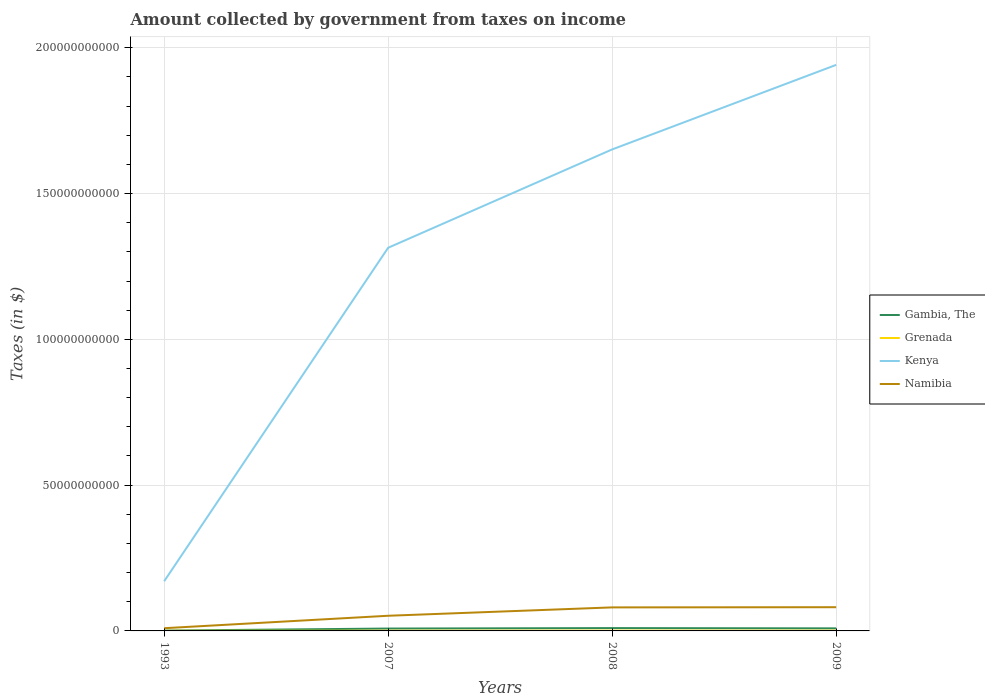How many different coloured lines are there?
Keep it short and to the point. 4. Does the line corresponding to Grenada intersect with the line corresponding to Gambia, The?
Ensure brevity in your answer.  No. Across all years, what is the maximum amount collected by government from taxes on income in Grenada?
Ensure brevity in your answer.  3.64e+07. What is the total amount collected by government from taxes on income in Namibia in the graph?
Provide a succinct answer. -2.94e+09. What is the difference between the highest and the second highest amount collected by government from taxes on income in Gambia, The?
Provide a succinct answer. 8.57e+08. Is the amount collected by government from taxes on income in Gambia, The strictly greater than the amount collected by government from taxes on income in Namibia over the years?
Your answer should be very brief. Yes. How many years are there in the graph?
Make the answer very short. 4. What is the difference between two consecutive major ticks on the Y-axis?
Offer a terse response. 5.00e+1. Are the values on the major ticks of Y-axis written in scientific E-notation?
Your answer should be very brief. No. How many legend labels are there?
Keep it short and to the point. 4. What is the title of the graph?
Offer a very short reply. Amount collected by government from taxes on income. Does "Aruba" appear as one of the legend labels in the graph?
Your answer should be very brief. No. What is the label or title of the Y-axis?
Give a very brief answer. Taxes (in $). What is the Taxes (in $) in Gambia, The in 1993?
Ensure brevity in your answer.  1.15e+08. What is the Taxes (in $) in Grenada in 1993?
Keep it short and to the point. 3.64e+07. What is the Taxes (in $) in Kenya in 1993?
Provide a succinct answer. 1.70e+1. What is the Taxes (in $) in Namibia in 1993?
Offer a very short reply. 9.30e+08. What is the Taxes (in $) of Gambia, The in 2007?
Ensure brevity in your answer.  8.16e+08. What is the Taxes (in $) in Grenada in 2007?
Your answer should be very brief. 7.48e+07. What is the Taxes (in $) in Kenya in 2007?
Offer a very short reply. 1.31e+11. What is the Taxes (in $) of Namibia in 2007?
Your response must be concise. 5.20e+09. What is the Taxes (in $) in Gambia, The in 2008?
Ensure brevity in your answer.  9.72e+08. What is the Taxes (in $) of Grenada in 2008?
Offer a very short reply. 9.46e+07. What is the Taxes (in $) in Kenya in 2008?
Provide a short and direct response. 1.65e+11. What is the Taxes (in $) of Namibia in 2008?
Your response must be concise. 8.07e+09. What is the Taxes (in $) of Gambia, The in 2009?
Keep it short and to the point. 8.81e+08. What is the Taxes (in $) in Grenada in 2009?
Your answer should be compact. 8.72e+07. What is the Taxes (in $) in Kenya in 2009?
Give a very brief answer. 1.94e+11. What is the Taxes (in $) in Namibia in 2009?
Offer a terse response. 8.14e+09. Across all years, what is the maximum Taxes (in $) of Gambia, The?
Give a very brief answer. 9.72e+08. Across all years, what is the maximum Taxes (in $) in Grenada?
Your response must be concise. 9.46e+07. Across all years, what is the maximum Taxes (in $) in Kenya?
Provide a short and direct response. 1.94e+11. Across all years, what is the maximum Taxes (in $) in Namibia?
Your answer should be compact. 8.14e+09. Across all years, what is the minimum Taxes (in $) in Gambia, The?
Offer a terse response. 1.15e+08. Across all years, what is the minimum Taxes (in $) of Grenada?
Make the answer very short. 3.64e+07. Across all years, what is the minimum Taxes (in $) in Kenya?
Your answer should be compact. 1.70e+1. Across all years, what is the minimum Taxes (in $) in Namibia?
Provide a short and direct response. 9.30e+08. What is the total Taxes (in $) of Gambia, The in the graph?
Offer a terse response. 2.78e+09. What is the total Taxes (in $) in Grenada in the graph?
Your response must be concise. 2.93e+08. What is the total Taxes (in $) of Kenya in the graph?
Offer a terse response. 5.08e+11. What is the total Taxes (in $) in Namibia in the graph?
Provide a short and direct response. 2.23e+1. What is the difference between the Taxes (in $) in Gambia, The in 1993 and that in 2007?
Your answer should be compact. -7.02e+08. What is the difference between the Taxes (in $) of Grenada in 1993 and that in 2007?
Offer a very short reply. -3.84e+07. What is the difference between the Taxes (in $) of Kenya in 1993 and that in 2007?
Offer a terse response. -1.14e+11. What is the difference between the Taxes (in $) in Namibia in 1993 and that in 2007?
Provide a succinct answer. -4.27e+09. What is the difference between the Taxes (in $) in Gambia, The in 1993 and that in 2008?
Provide a succinct answer. -8.57e+08. What is the difference between the Taxes (in $) in Grenada in 1993 and that in 2008?
Give a very brief answer. -5.82e+07. What is the difference between the Taxes (in $) of Kenya in 1993 and that in 2008?
Provide a short and direct response. -1.48e+11. What is the difference between the Taxes (in $) in Namibia in 1993 and that in 2008?
Provide a succinct answer. -7.14e+09. What is the difference between the Taxes (in $) of Gambia, The in 1993 and that in 2009?
Your response must be concise. -7.67e+08. What is the difference between the Taxes (in $) in Grenada in 1993 and that in 2009?
Your answer should be very brief. -5.08e+07. What is the difference between the Taxes (in $) of Kenya in 1993 and that in 2009?
Give a very brief answer. -1.77e+11. What is the difference between the Taxes (in $) of Namibia in 1993 and that in 2009?
Your response must be concise. -7.21e+09. What is the difference between the Taxes (in $) in Gambia, The in 2007 and that in 2008?
Give a very brief answer. -1.56e+08. What is the difference between the Taxes (in $) in Grenada in 2007 and that in 2008?
Give a very brief answer. -1.98e+07. What is the difference between the Taxes (in $) in Kenya in 2007 and that in 2008?
Give a very brief answer. -3.37e+1. What is the difference between the Taxes (in $) of Namibia in 2007 and that in 2008?
Offer a very short reply. -2.87e+09. What is the difference between the Taxes (in $) of Gambia, The in 2007 and that in 2009?
Make the answer very short. -6.50e+07. What is the difference between the Taxes (in $) in Grenada in 2007 and that in 2009?
Provide a succinct answer. -1.24e+07. What is the difference between the Taxes (in $) in Kenya in 2007 and that in 2009?
Give a very brief answer. -6.27e+1. What is the difference between the Taxes (in $) of Namibia in 2007 and that in 2009?
Give a very brief answer. -2.94e+09. What is the difference between the Taxes (in $) in Gambia, The in 2008 and that in 2009?
Your answer should be compact. 9.08e+07. What is the difference between the Taxes (in $) in Grenada in 2008 and that in 2009?
Your answer should be very brief. 7.40e+06. What is the difference between the Taxes (in $) of Kenya in 2008 and that in 2009?
Provide a short and direct response. -2.90e+1. What is the difference between the Taxes (in $) in Namibia in 2008 and that in 2009?
Offer a very short reply. -6.70e+07. What is the difference between the Taxes (in $) of Gambia, The in 1993 and the Taxes (in $) of Grenada in 2007?
Offer a terse response. 3.99e+07. What is the difference between the Taxes (in $) of Gambia, The in 1993 and the Taxes (in $) of Kenya in 2007?
Keep it short and to the point. -1.31e+11. What is the difference between the Taxes (in $) of Gambia, The in 1993 and the Taxes (in $) of Namibia in 2007?
Your response must be concise. -5.09e+09. What is the difference between the Taxes (in $) in Grenada in 1993 and the Taxes (in $) in Kenya in 2007?
Provide a succinct answer. -1.31e+11. What is the difference between the Taxes (in $) in Grenada in 1993 and the Taxes (in $) in Namibia in 2007?
Keep it short and to the point. -5.16e+09. What is the difference between the Taxes (in $) of Kenya in 1993 and the Taxes (in $) of Namibia in 2007?
Your answer should be very brief. 1.18e+1. What is the difference between the Taxes (in $) in Gambia, The in 1993 and the Taxes (in $) in Grenada in 2008?
Provide a succinct answer. 2.01e+07. What is the difference between the Taxes (in $) in Gambia, The in 1993 and the Taxes (in $) in Kenya in 2008?
Make the answer very short. -1.65e+11. What is the difference between the Taxes (in $) of Gambia, The in 1993 and the Taxes (in $) of Namibia in 2008?
Keep it short and to the point. -7.95e+09. What is the difference between the Taxes (in $) in Grenada in 1993 and the Taxes (in $) in Kenya in 2008?
Your answer should be very brief. -1.65e+11. What is the difference between the Taxes (in $) in Grenada in 1993 and the Taxes (in $) in Namibia in 2008?
Offer a terse response. -8.03e+09. What is the difference between the Taxes (in $) of Kenya in 1993 and the Taxes (in $) of Namibia in 2008?
Offer a very short reply. 8.96e+09. What is the difference between the Taxes (in $) of Gambia, The in 1993 and the Taxes (in $) of Grenada in 2009?
Your answer should be very brief. 2.75e+07. What is the difference between the Taxes (in $) of Gambia, The in 1993 and the Taxes (in $) of Kenya in 2009?
Ensure brevity in your answer.  -1.94e+11. What is the difference between the Taxes (in $) in Gambia, The in 1993 and the Taxes (in $) in Namibia in 2009?
Your answer should be very brief. -8.02e+09. What is the difference between the Taxes (in $) of Grenada in 1993 and the Taxes (in $) of Kenya in 2009?
Make the answer very short. -1.94e+11. What is the difference between the Taxes (in $) in Grenada in 1993 and the Taxes (in $) in Namibia in 2009?
Make the answer very short. -8.10e+09. What is the difference between the Taxes (in $) of Kenya in 1993 and the Taxes (in $) of Namibia in 2009?
Provide a short and direct response. 8.89e+09. What is the difference between the Taxes (in $) in Gambia, The in 2007 and the Taxes (in $) in Grenada in 2008?
Your response must be concise. 7.22e+08. What is the difference between the Taxes (in $) of Gambia, The in 2007 and the Taxes (in $) of Kenya in 2008?
Your answer should be compact. -1.64e+11. What is the difference between the Taxes (in $) in Gambia, The in 2007 and the Taxes (in $) in Namibia in 2008?
Your answer should be compact. -7.25e+09. What is the difference between the Taxes (in $) in Grenada in 2007 and the Taxes (in $) in Kenya in 2008?
Give a very brief answer. -1.65e+11. What is the difference between the Taxes (in $) in Grenada in 2007 and the Taxes (in $) in Namibia in 2008?
Keep it short and to the point. -7.99e+09. What is the difference between the Taxes (in $) of Kenya in 2007 and the Taxes (in $) of Namibia in 2008?
Your answer should be compact. 1.23e+11. What is the difference between the Taxes (in $) of Gambia, The in 2007 and the Taxes (in $) of Grenada in 2009?
Make the answer very short. 7.29e+08. What is the difference between the Taxes (in $) of Gambia, The in 2007 and the Taxes (in $) of Kenya in 2009?
Keep it short and to the point. -1.93e+11. What is the difference between the Taxes (in $) of Gambia, The in 2007 and the Taxes (in $) of Namibia in 2009?
Ensure brevity in your answer.  -7.32e+09. What is the difference between the Taxes (in $) in Grenada in 2007 and the Taxes (in $) in Kenya in 2009?
Make the answer very short. -1.94e+11. What is the difference between the Taxes (in $) of Grenada in 2007 and the Taxes (in $) of Namibia in 2009?
Your answer should be very brief. -8.06e+09. What is the difference between the Taxes (in $) in Kenya in 2007 and the Taxes (in $) in Namibia in 2009?
Make the answer very short. 1.23e+11. What is the difference between the Taxes (in $) of Gambia, The in 2008 and the Taxes (in $) of Grenada in 2009?
Your answer should be compact. 8.85e+08. What is the difference between the Taxes (in $) in Gambia, The in 2008 and the Taxes (in $) in Kenya in 2009?
Your answer should be compact. -1.93e+11. What is the difference between the Taxes (in $) of Gambia, The in 2008 and the Taxes (in $) of Namibia in 2009?
Provide a succinct answer. -7.16e+09. What is the difference between the Taxes (in $) in Grenada in 2008 and the Taxes (in $) in Kenya in 2009?
Your response must be concise. -1.94e+11. What is the difference between the Taxes (in $) in Grenada in 2008 and the Taxes (in $) in Namibia in 2009?
Provide a short and direct response. -8.04e+09. What is the difference between the Taxes (in $) of Kenya in 2008 and the Taxes (in $) of Namibia in 2009?
Make the answer very short. 1.57e+11. What is the average Taxes (in $) in Gambia, The per year?
Ensure brevity in your answer.  6.96e+08. What is the average Taxes (in $) in Grenada per year?
Offer a very short reply. 7.33e+07. What is the average Taxes (in $) of Kenya per year?
Provide a short and direct response. 1.27e+11. What is the average Taxes (in $) of Namibia per year?
Keep it short and to the point. 5.58e+09. In the year 1993, what is the difference between the Taxes (in $) in Gambia, The and Taxes (in $) in Grenada?
Your response must be concise. 7.83e+07. In the year 1993, what is the difference between the Taxes (in $) of Gambia, The and Taxes (in $) of Kenya?
Ensure brevity in your answer.  -1.69e+1. In the year 1993, what is the difference between the Taxes (in $) of Gambia, The and Taxes (in $) of Namibia?
Give a very brief answer. -8.16e+08. In the year 1993, what is the difference between the Taxes (in $) of Grenada and Taxes (in $) of Kenya?
Provide a succinct answer. -1.70e+1. In the year 1993, what is the difference between the Taxes (in $) in Grenada and Taxes (in $) in Namibia?
Your answer should be very brief. -8.94e+08. In the year 1993, what is the difference between the Taxes (in $) in Kenya and Taxes (in $) in Namibia?
Provide a succinct answer. 1.61e+1. In the year 2007, what is the difference between the Taxes (in $) in Gambia, The and Taxes (in $) in Grenada?
Offer a terse response. 7.42e+08. In the year 2007, what is the difference between the Taxes (in $) of Gambia, The and Taxes (in $) of Kenya?
Provide a succinct answer. -1.31e+11. In the year 2007, what is the difference between the Taxes (in $) of Gambia, The and Taxes (in $) of Namibia?
Offer a very short reply. -4.38e+09. In the year 2007, what is the difference between the Taxes (in $) of Grenada and Taxes (in $) of Kenya?
Ensure brevity in your answer.  -1.31e+11. In the year 2007, what is the difference between the Taxes (in $) in Grenada and Taxes (in $) in Namibia?
Provide a succinct answer. -5.13e+09. In the year 2007, what is the difference between the Taxes (in $) in Kenya and Taxes (in $) in Namibia?
Offer a terse response. 1.26e+11. In the year 2008, what is the difference between the Taxes (in $) of Gambia, The and Taxes (in $) of Grenada?
Your answer should be very brief. 8.78e+08. In the year 2008, what is the difference between the Taxes (in $) of Gambia, The and Taxes (in $) of Kenya?
Provide a succinct answer. -1.64e+11. In the year 2008, what is the difference between the Taxes (in $) in Gambia, The and Taxes (in $) in Namibia?
Your answer should be compact. -7.10e+09. In the year 2008, what is the difference between the Taxes (in $) in Grenada and Taxes (in $) in Kenya?
Ensure brevity in your answer.  -1.65e+11. In the year 2008, what is the difference between the Taxes (in $) of Grenada and Taxes (in $) of Namibia?
Your answer should be compact. -7.98e+09. In the year 2008, what is the difference between the Taxes (in $) of Kenya and Taxes (in $) of Namibia?
Offer a very short reply. 1.57e+11. In the year 2009, what is the difference between the Taxes (in $) in Gambia, The and Taxes (in $) in Grenada?
Provide a short and direct response. 7.94e+08. In the year 2009, what is the difference between the Taxes (in $) in Gambia, The and Taxes (in $) in Kenya?
Make the answer very short. -1.93e+11. In the year 2009, what is the difference between the Taxes (in $) of Gambia, The and Taxes (in $) of Namibia?
Ensure brevity in your answer.  -7.26e+09. In the year 2009, what is the difference between the Taxes (in $) of Grenada and Taxes (in $) of Kenya?
Your response must be concise. -1.94e+11. In the year 2009, what is the difference between the Taxes (in $) in Grenada and Taxes (in $) in Namibia?
Make the answer very short. -8.05e+09. In the year 2009, what is the difference between the Taxes (in $) in Kenya and Taxes (in $) in Namibia?
Your answer should be very brief. 1.86e+11. What is the ratio of the Taxes (in $) of Gambia, The in 1993 to that in 2007?
Offer a terse response. 0.14. What is the ratio of the Taxes (in $) in Grenada in 1993 to that in 2007?
Offer a very short reply. 0.49. What is the ratio of the Taxes (in $) of Kenya in 1993 to that in 2007?
Make the answer very short. 0.13. What is the ratio of the Taxes (in $) of Namibia in 1993 to that in 2007?
Your response must be concise. 0.18. What is the ratio of the Taxes (in $) of Gambia, The in 1993 to that in 2008?
Your answer should be very brief. 0.12. What is the ratio of the Taxes (in $) in Grenada in 1993 to that in 2008?
Offer a very short reply. 0.39. What is the ratio of the Taxes (in $) of Kenya in 1993 to that in 2008?
Your answer should be compact. 0.1. What is the ratio of the Taxes (in $) of Namibia in 1993 to that in 2008?
Offer a terse response. 0.12. What is the ratio of the Taxes (in $) of Gambia, The in 1993 to that in 2009?
Make the answer very short. 0.13. What is the ratio of the Taxes (in $) of Grenada in 1993 to that in 2009?
Keep it short and to the point. 0.42. What is the ratio of the Taxes (in $) of Kenya in 1993 to that in 2009?
Ensure brevity in your answer.  0.09. What is the ratio of the Taxes (in $) in Namibia in 1993 to that in 2009?
Give a very brief answer. 0.11. What is the ratio of the Taxes (in $) in Gambia, The in 2007 to that in 2008?
Make the answer very short. 0.84. What is the ratio of the Taxes (in $) of Grenada in 2007 to that in 2008?
Offer a terse response. 0.79. What is the ratio of the Taxes (in $) in Kenya in 2007 to that in 2008?
Provide a short and direct response. 0.8. What is the ratio of the Taxes (in $) in Namibia in 2007 to that in 2008?
Provide a short and direct response. 0.64. What is the ratio of the Taxes (in $) of Gambia, The in 2007 to that in 2009?
Offer a terse response. 0.93. What is the ratio of the Taxes (in $) in Grenada in 2007 to that in 2009?
Make the answer very short. 0.86. What is the ratio of the Taxes (in $) of Kenya in 2007 to that in 2009?
Make the answer very short. 0.68. What is the ratio of the Taxes (in $) in Namibia in 2007 to that in 2009?
Offer a very short reply. 0.64. What is the ratio of the Taxes (in $) in Gambia, The in 2008 to that in 2009?
Provide a succinct answer. 1.1. What is the ratio of the Taxes (in $) in Grenada in 2008 to that in 2009?
Keep it short and to the point. 1.08. What is the ratio of the Taxes (in $) in Kenya in 2008 to that in 2009?
Your answer should be compact. 0.85. What is the difference between the highest and the second highest Taxes (in $) of Gambia, The?
Your answer should be very brief. 9.08e+07. What is the difference between the highest and the second highest Taxes (in $) of Grenada?
Your response must be concise. 7.40e+06. What is the difference between the highest and the second highest Taxes (in $) in Kenya?
Give a very brief answer. 2.90e+1. What is the difference between the highest and the second highest Taxes (in $) of Namibia?
Offer a terse response. 6.70e+07. What is the difference between the highest and the lowest Taxes (in $) of Gambia, The?
Offer a terse response. 8.57e+08. What is the difference between the highest and the lowest Taxes (in $) of Grenada?
Provide a short and direct response. 5.82e+07. What is the difference between the highest and the lowest Taxes (in $) in Kenya?
Keep it short and to the point. 1.77e+11. What is the difference between the highest and the lowest Taxes (in $) of Namibia?
Your answer should be very brief. 7.21e+09. 